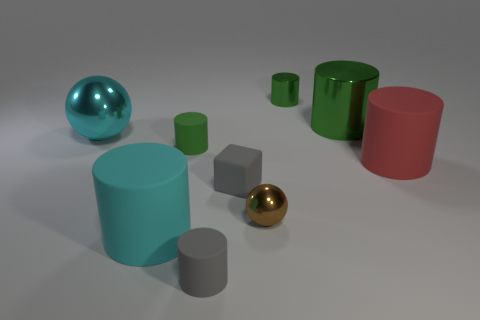Subtract all small gray cylinders. How many cylinders are left? 5 Subtract all brown blocks. How many green cylinders are left? 3 Subtract all red cylinders. How many cylinders are left? 5 Add 1 spheres. How many objects exist? 10 Subtract all red cylinders. Subtract all brown cubes. How many cylinders are left? 5 Subtract all balls. How many objects are left? 7 Add 4 green metallic cylinders. How many green metallic cylinders are left? 6 Add 4 tiny things. How many tiny things exist? 9 Subtract 0 brown cylinders. How many objects are left? 9 Subtract all tiny brown metallic balls. Subtract all big cyan things. How many objects are left? 6 